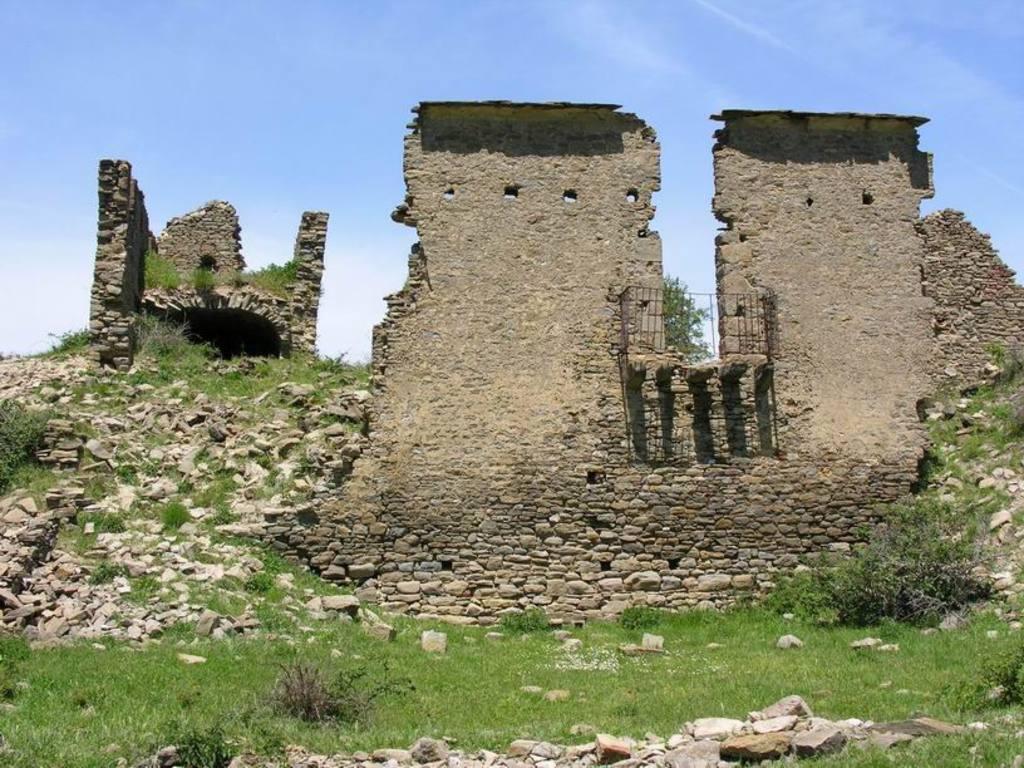Describe this image in one or two sentences. In this image we can see a wall. On the wall there is a railing. Beside the wall we can see rocks and a wall. On the rocks we can see few plants. At the bottom we can see the grass and the rocks. At the top we can see the sky. 